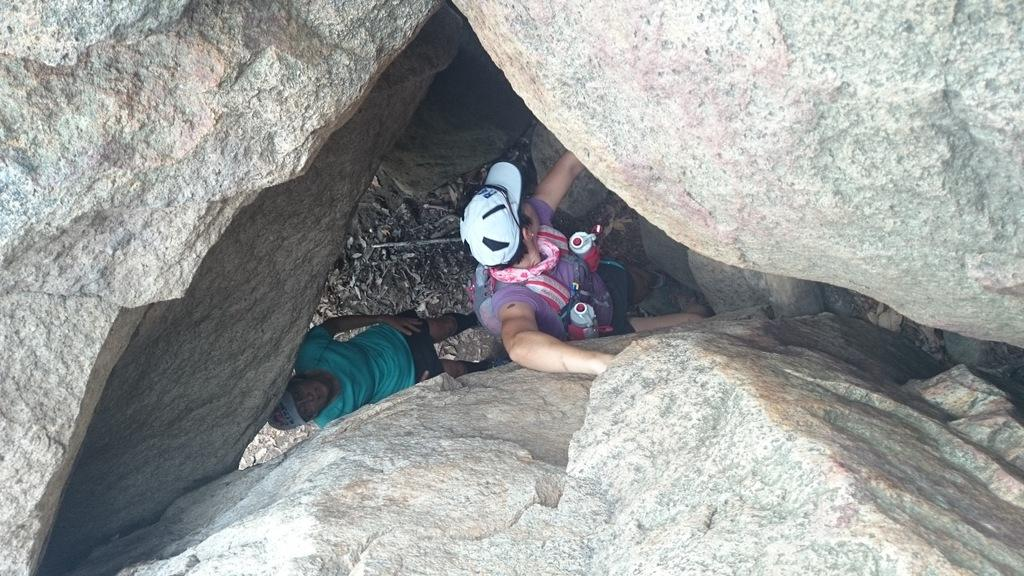How many people are in the image? There are two persons standing in the image. What are the persons wearing on their heads? The persons are wearing caps. What type of natural elements can be seen in the image? There are rocks visible in the image. What objects are located at the bottom of the image? There are sticks at the bottom of the image. What type of tent can be seen in the image? There is no tent present in the image. What discovery was made by the persons in the image? The image does not depict any discovery made by the persons. 